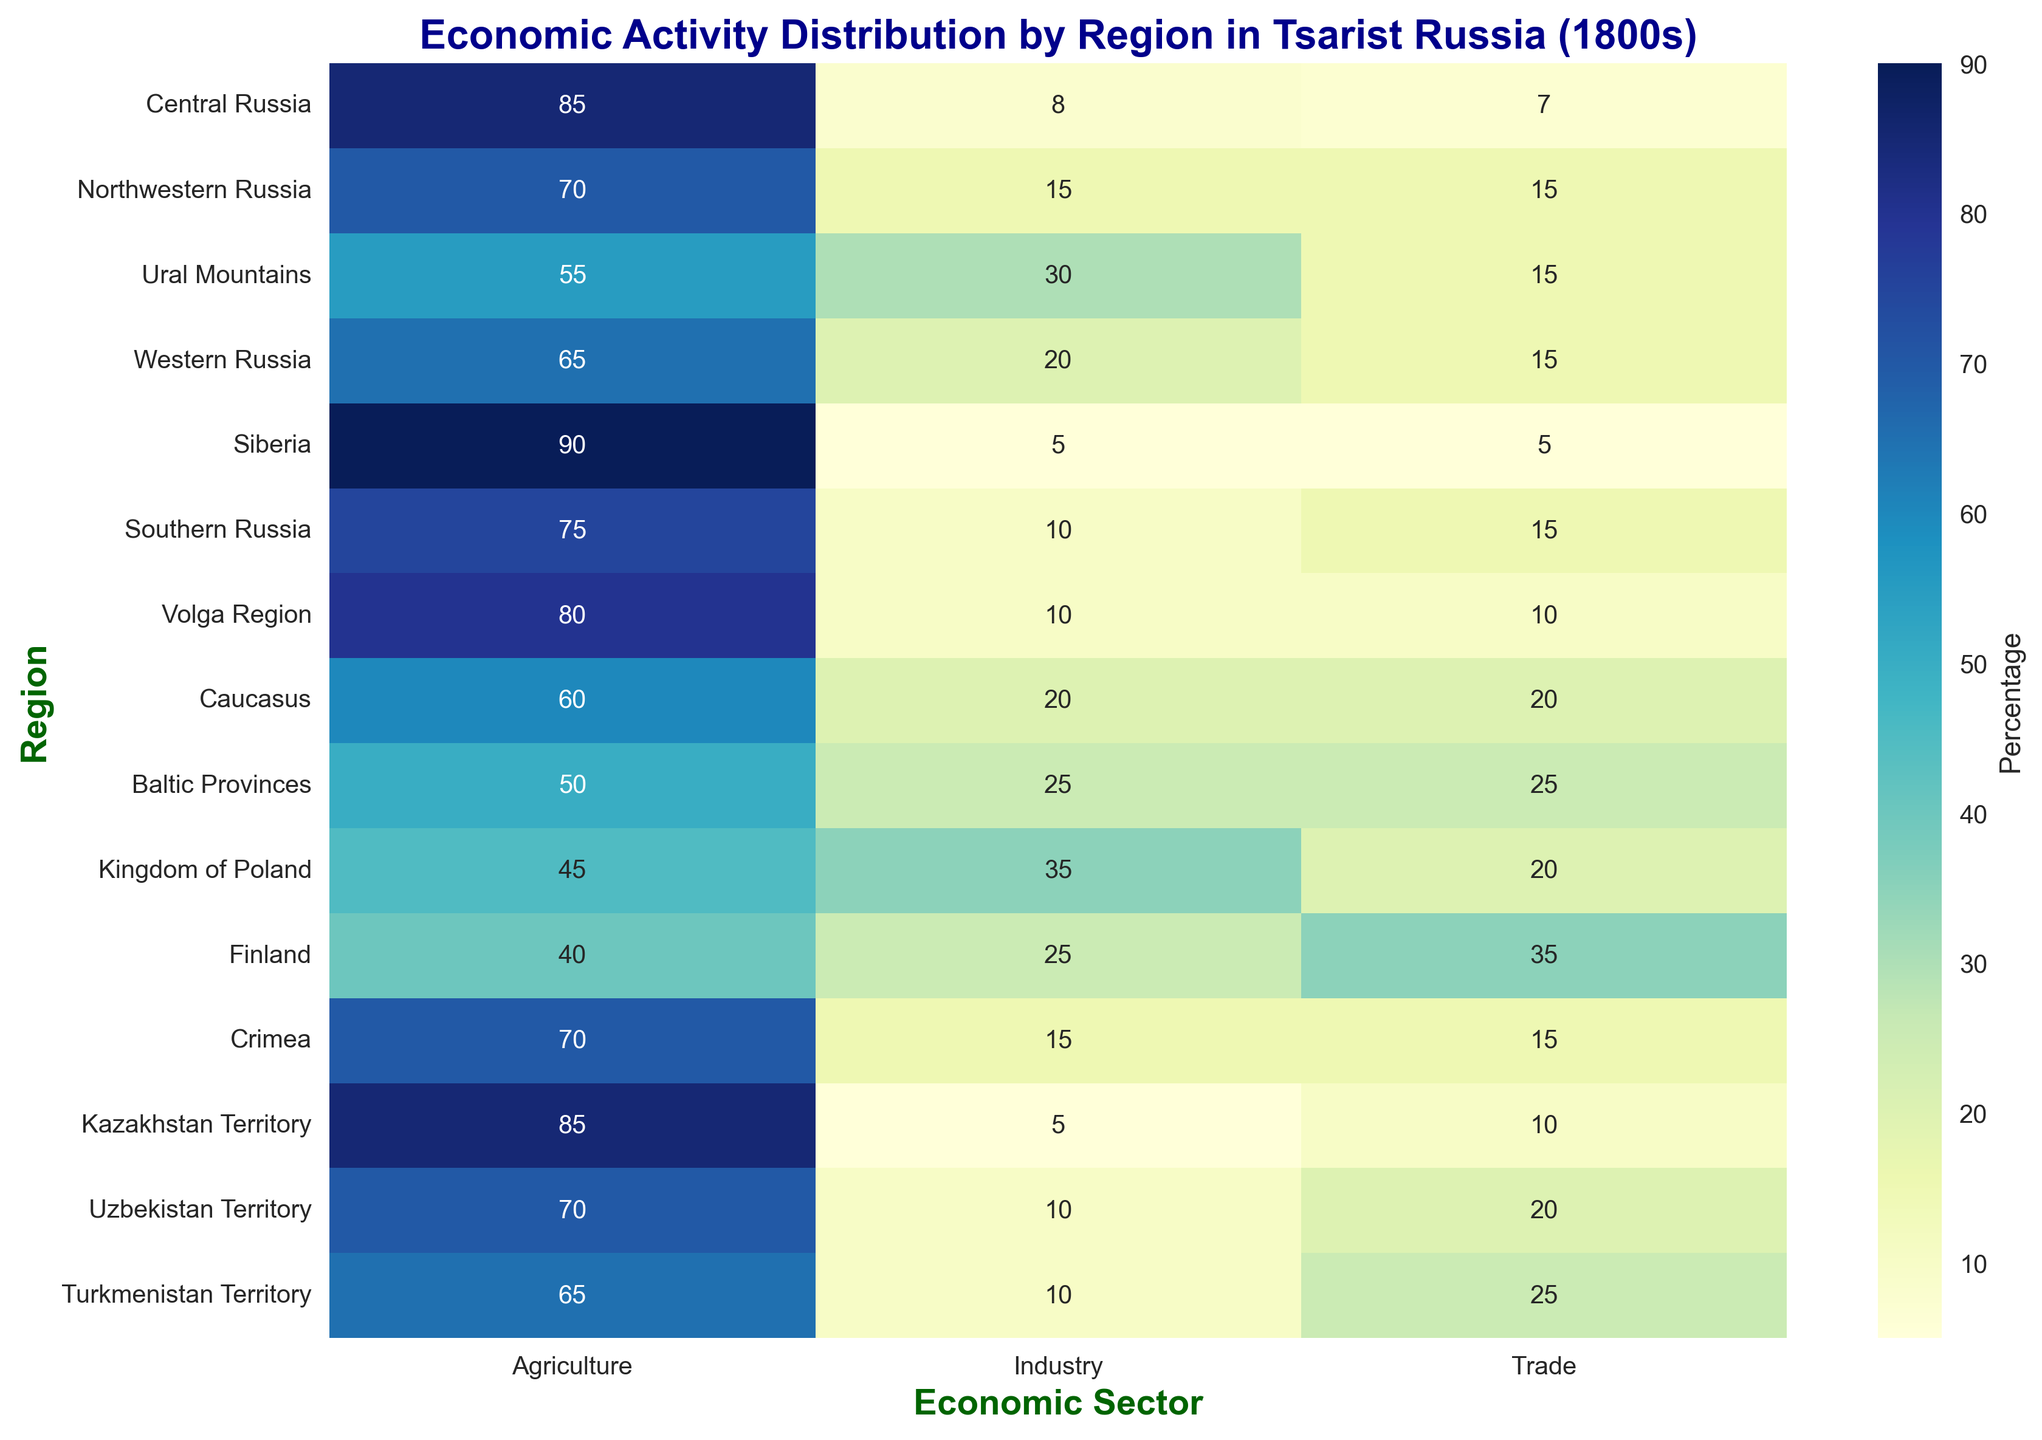Which region has the highest percentage dedicated to agriculture? In the heatmap, we look at the column for agriculture and identify the region with the highest percentage value. The highest percentage for agriculture is 90%, which belongs to Siberia.
Answer: Siberia Which region has the lowest percentage for trade? By examining the trade column in the heatmap, we look for the lowest percentage value, which is 5%. This value is shared by Siberia and Kazakhstan Territory.
Answer: Siberia, Kazakhstan Territory What is the average percentage of industry across all regions? To find the average, sum all the percentages for the industry column and divide by the number of regions. The percentages are 8, 15, 30, 20, 5, 10, 10, 20, 25, 35, 25, 15, 5, 10, 10, summing up to 233. Dividing by 15 (total regions) gives approximately 15.53%.
Answer: 15.53% Which region is most balanced in its economic activity distribution? A balanced economic activity distribution would imply that the percentages for agriculture, industry, and trade are closest to each other across a region. Observing the heatmap, Baltic Provinces with values of 50, 25, 25 and Uzbekistan Territory with values of 70, 10, 20 seem more balanced but Baltic Provinces is more equally spread out.
Answer: Baltic Provinces How does the industry percentage in Central Russia compare to the industry percentage in the Kingdom of Poland? From the heatmap, Central Russia has 8% in industry whereas the Kingdom of Poland has 35%. Therefore, the industry percentage in the Kingdom of Poland is higher.
Answer: Higher in Kingdom of Poland Which region has a higher percentage of trade: Caucasus or Turkmenistan Territory? Referring to the heatmap, both the Caucasus and Turkmenistan Territory have a trade percentage of 20 and 25 respectively. Therefore, Turkmenistan Territory has a higher trade percentage.
Answer: Turkmenistan Territory In which regions is agriculture more than 75%? By scanning the agriculture column in the heatmap, the regions where agriculture is more than 75% are Central Russia (85%), Siberia (90%), Volga Region (80%), Kazakhstan Territory (85%).
Answer: Central Russia, Siberia, Volga Region, Kazakhstan Territory Calculate the total percentage dedicated to trade in the Northwestern Russia and Crimea combined. Find the trade percentages for Northwestern Russia (15%) and Crimea (15%), and sum them up. The total is 30%.
Answer: 30% Which sector is the least dominant in the Volga Region? For the Volga Region, examining the percentages for agriculture (80%), industry (10%), and trade (10%), the least dominant sector is both industry and trade with 10%.
Answer: Industry and Trade 